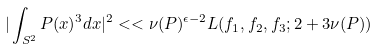Convert formula to latex. <formula><loc_0><loc_0><loc_500><loc_500>| \int _ { S ^ { 2 } } P ( x ) ^ { 3 } d x | ^ { 2 } < < \nu ( P ) ^ { \epsilon - 2 } L ( f _ { 1 } , f _ { 2 } , f _ { 3 } ; 2 + 3 \nu ( P ) )</formula> 